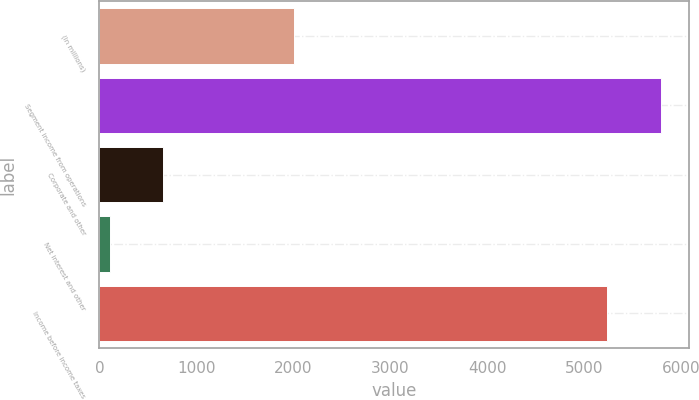Convert chart to OTSL. <chart><loc_0><loc_0><loc_500><loc_500><bar_chart><fcel>(In millions)<fcel>Segment income from operations<fcel>Corporate and other<fcel>Net interest and other<fcel>Income before income taxes<nl><fcel>2012<fcel>5789.5<fcel>660.5<fcel>109<fcel>5238<nl></chart> 